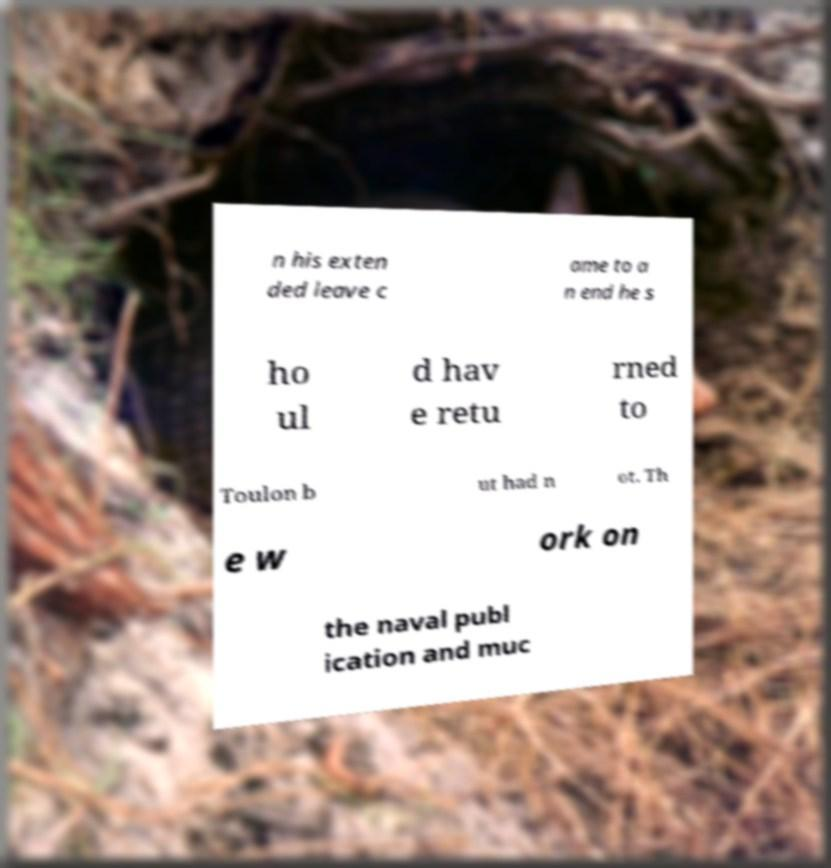For documentation purposes, I need the text within this image transcribed. Could you provide that? n his exten ded leave c ame to a n end he s ho ul d hav e retu rned to Toulon b ut had n ot. Th e w ork on the naval publ ication and muc 